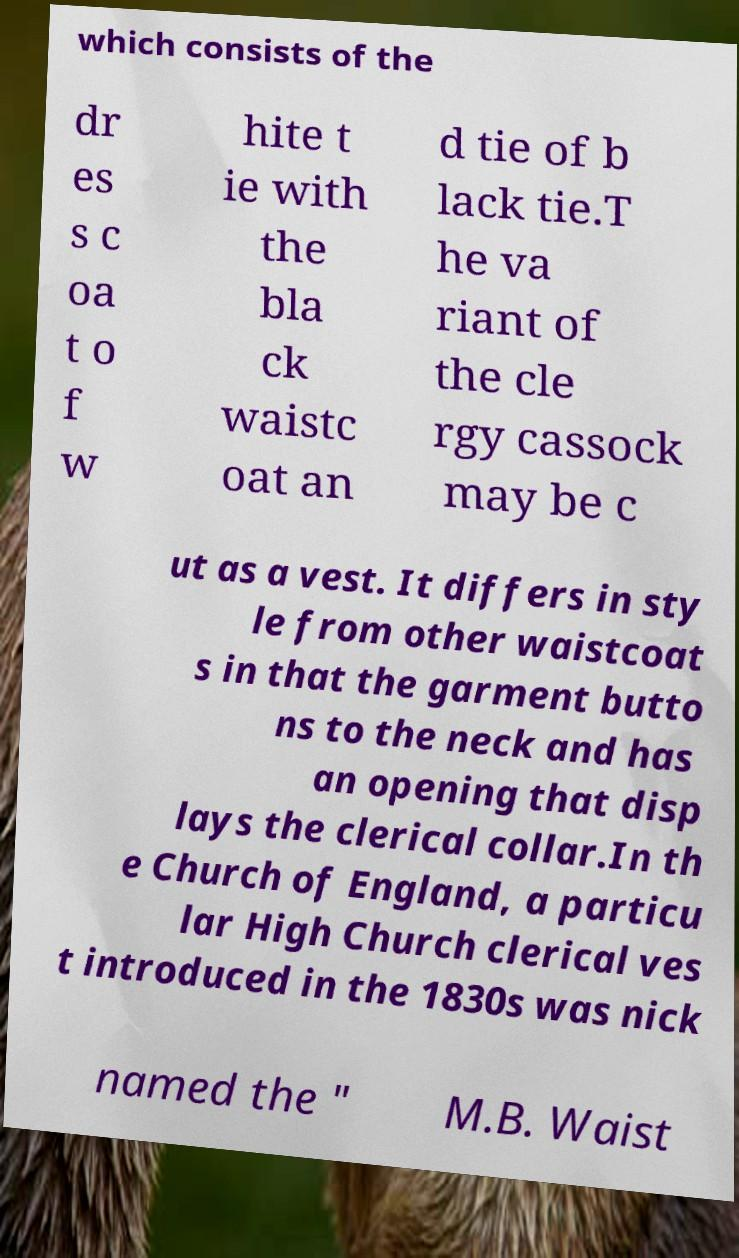Could you assist in decoding the text presented in this image and type it out clearly? which consists of the dr es s c oa t o f w hite t ie with the bla ck waistc oat an d tie of b lack tie.T he va riant of the cle rgy cassock may be c ut as a vest. It differs in sty le from other waistcoat s in that the garment butto ns to the neck and has an opening that disp lays the clerical collar.In th e Church of England, a particu lar High Church clerical ves t introduced in the 1830s was nick named the " M.B. Waist 